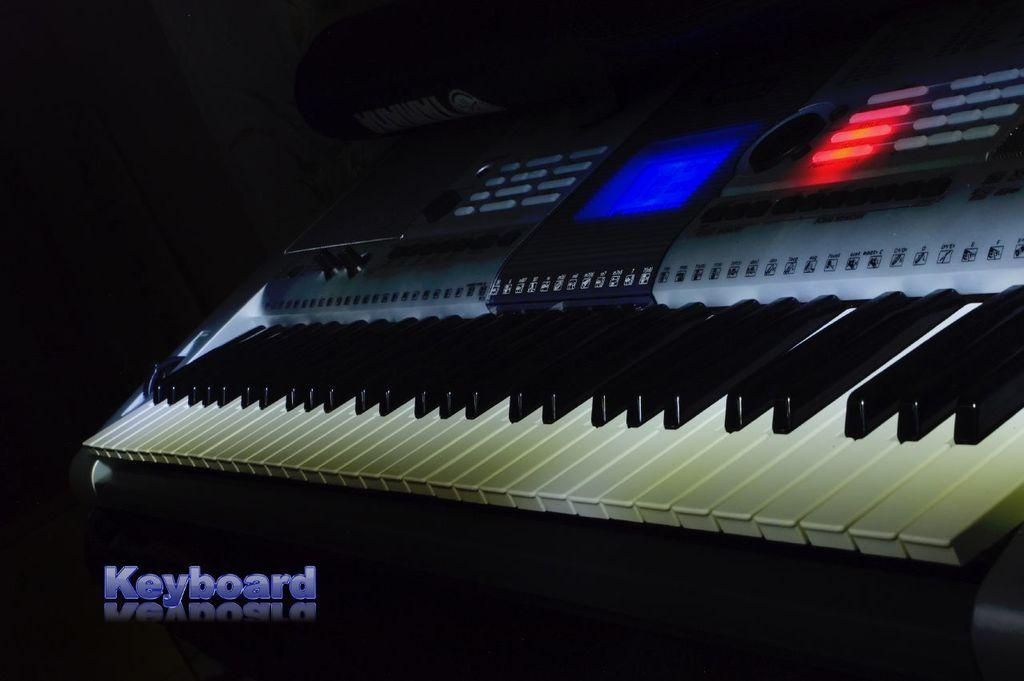What is the main object in the image? There is a keyboard in the image. What might the keyboard be used for? The keyboard is likely used for typing or inputting data. Can you describe the appearance of the keyboard? The image only shows the keyboard, so it's not possible to provide a detailed description of its appearance. How many clovers are growing around the keyboard in the image? There are no clovers present in the image; it only features a keyboard. 